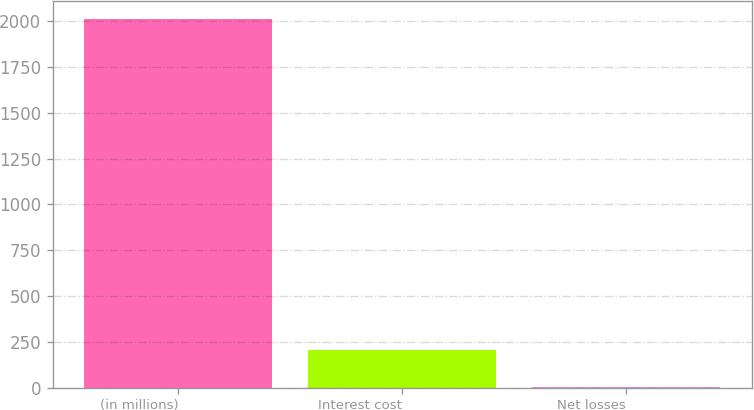<chart> <loc_0><loc_0><loc_500><loc_500><bar_chart><fcel>(in millions)<fcel>Interest cost<fcel>Net losses<nl><fcel>2013<fcel>203.1<fcel>2<nl></chart> 